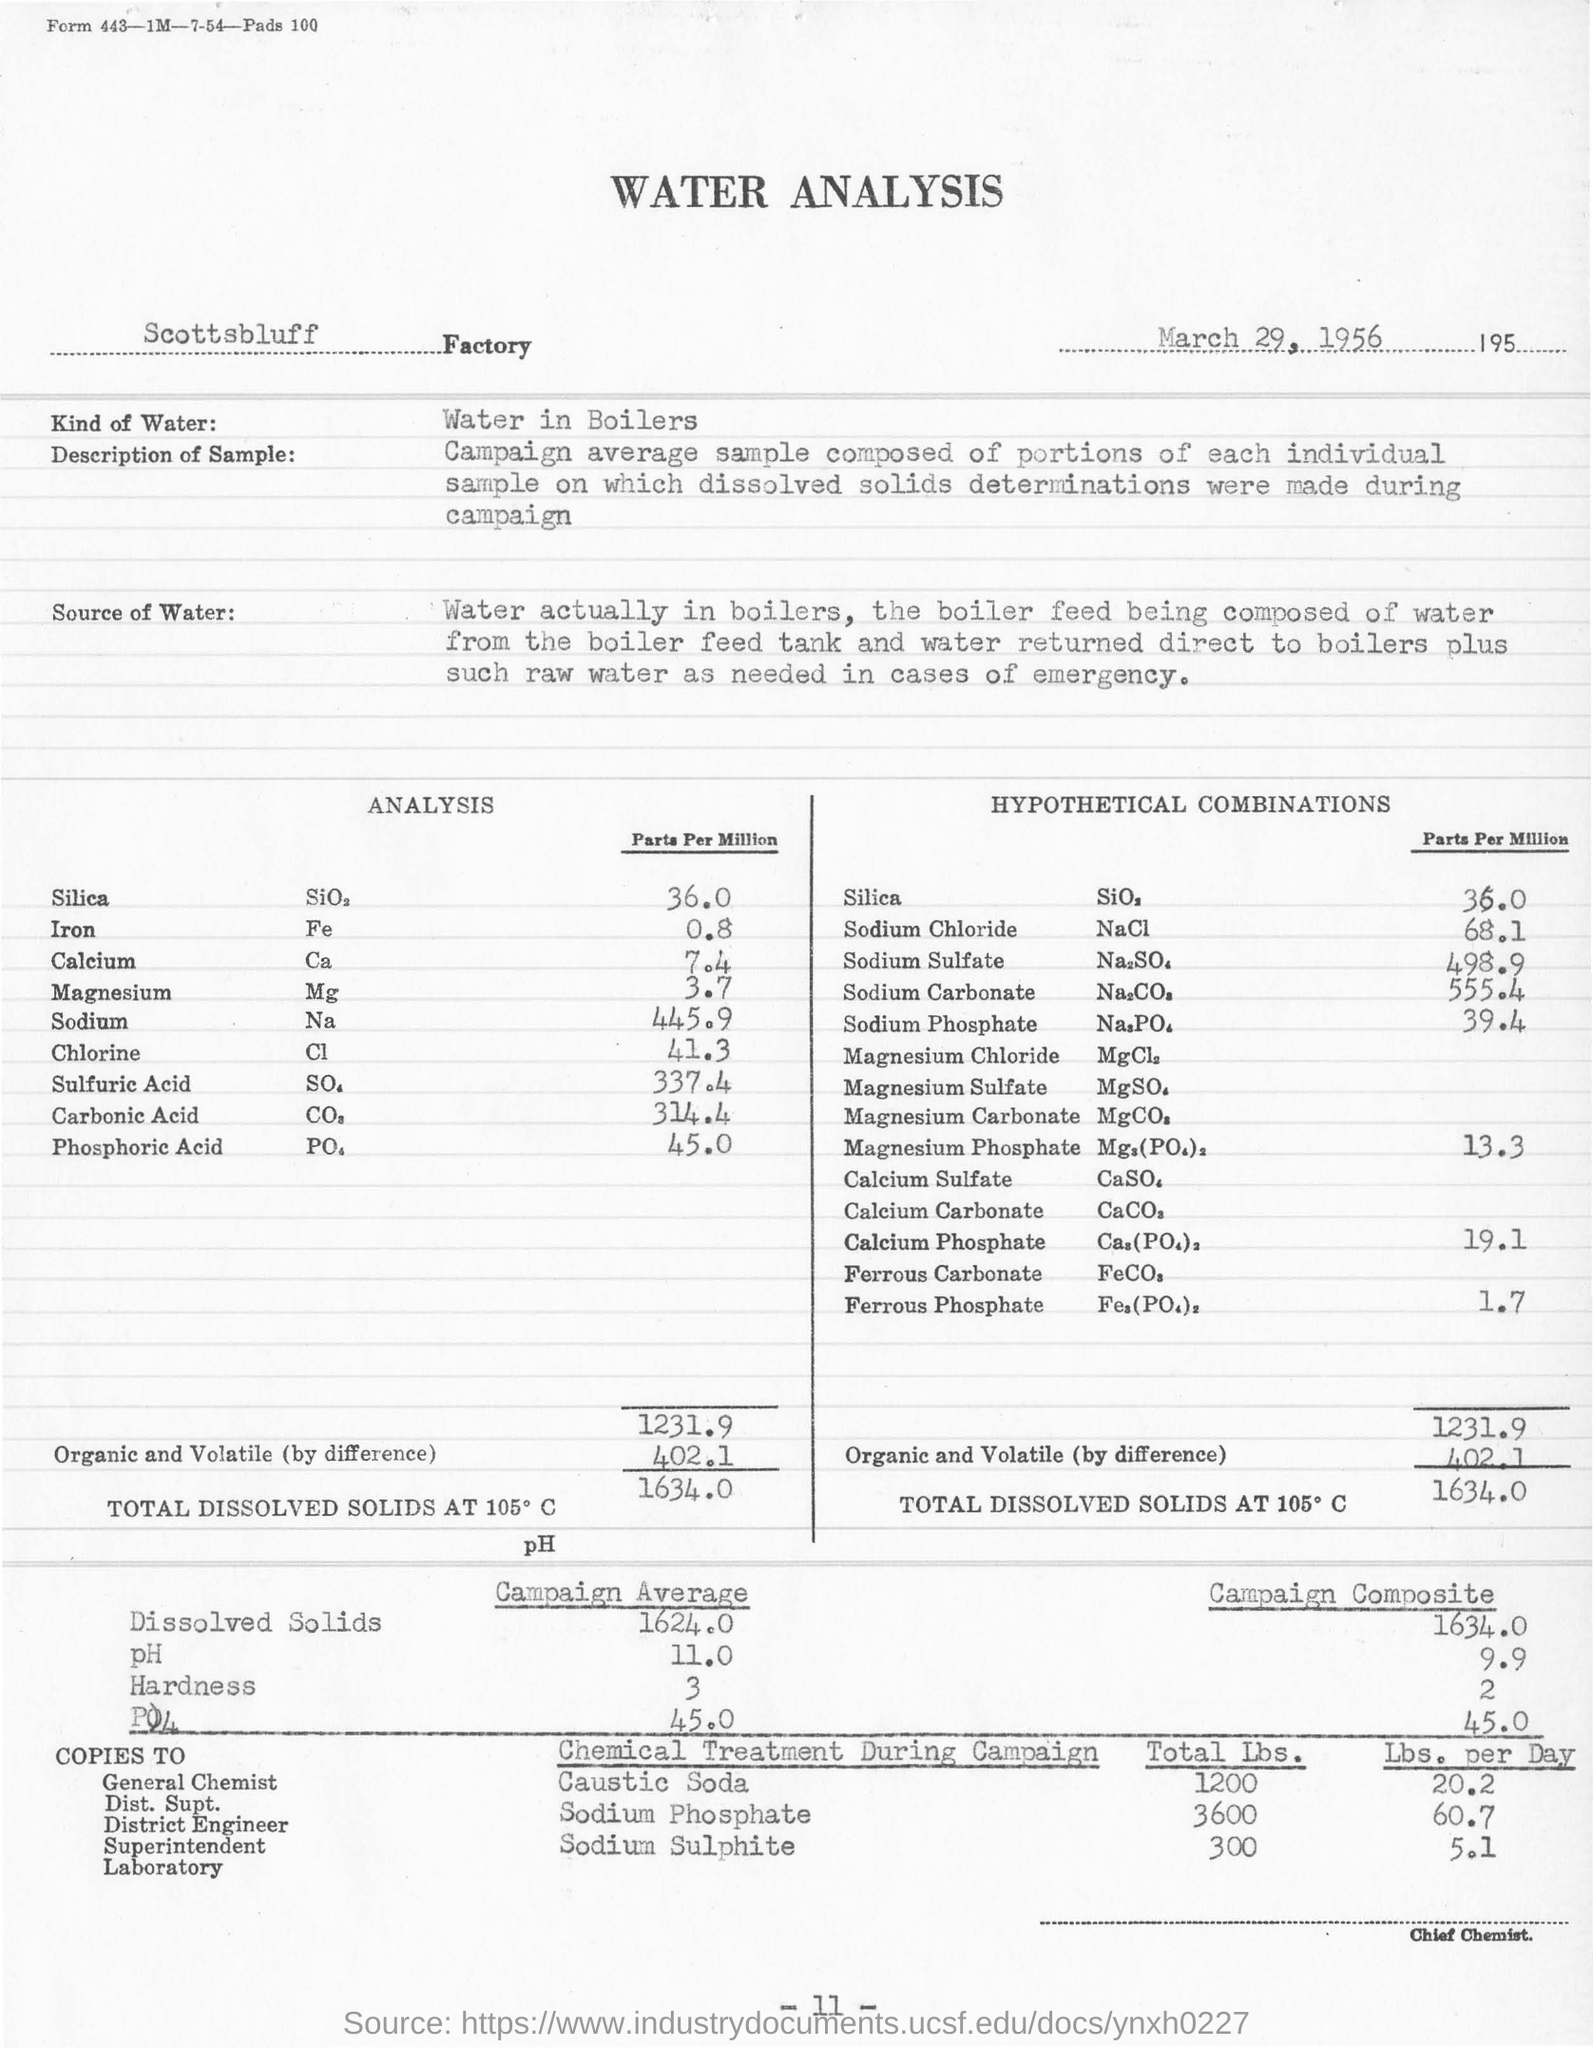Highlight a few significant elements in this photo. The total amount of caustic soda used was 1,200 pounds. The value entered in the field "Kind of Water" is "Water in boilers. The analysis was conducted on March 29, 1956. 